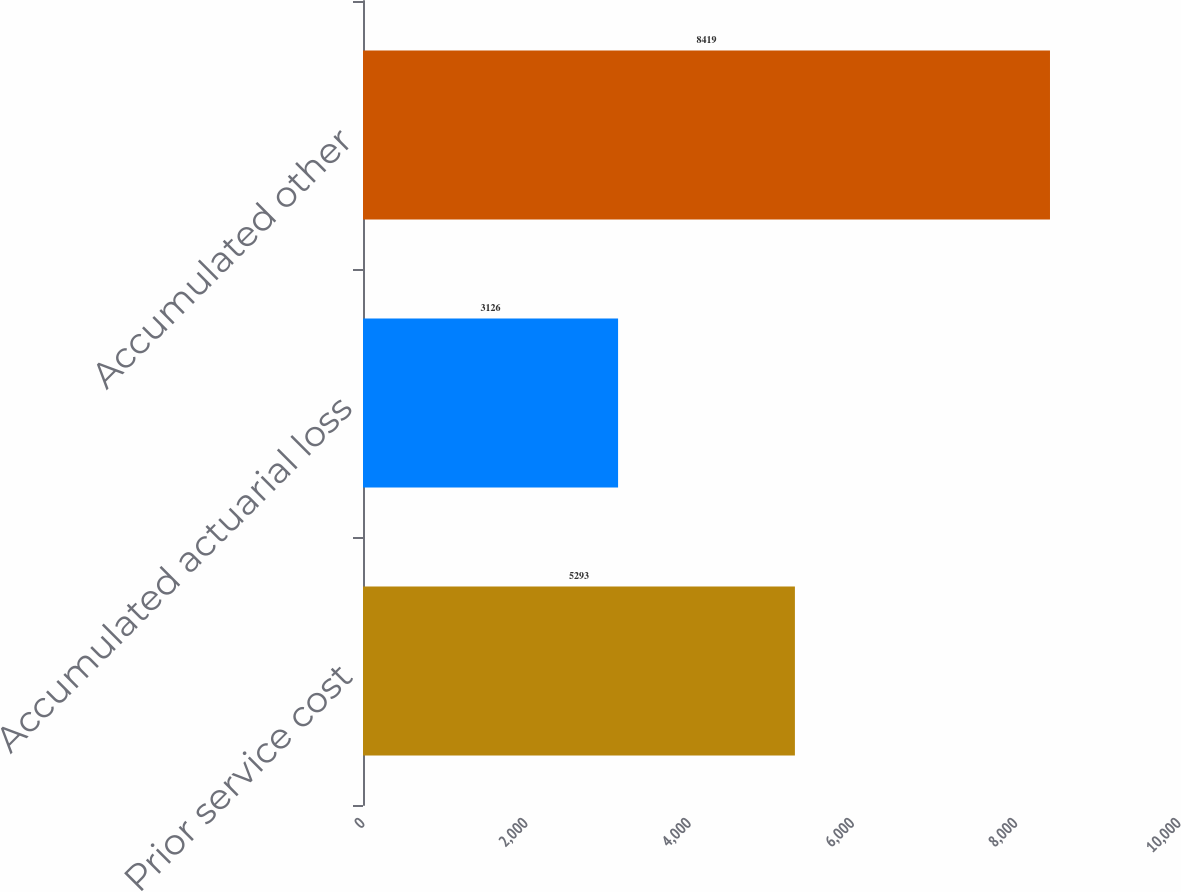<chart> <loc_0><loc_0><loc_500><loc_500><bar_chart><fcel>Prior service cost<fcel>Accumulated actuarial loss<fcel>Accumulated other<nl><fcel>5293<fcel>3126<fcel>8419<nl></chart> 